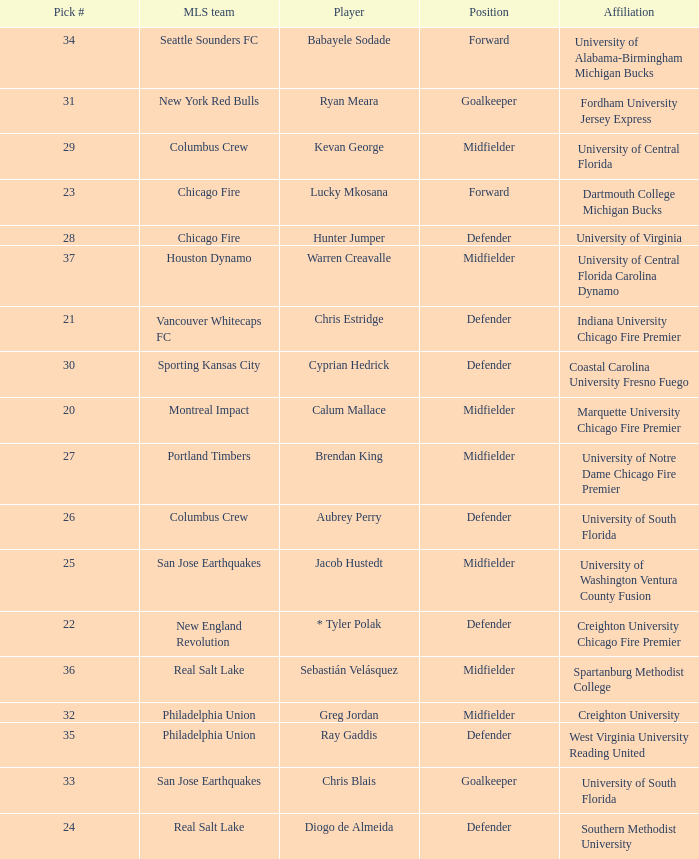What pick number did Real Salt Lake get? 24.0. 